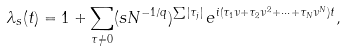Convert formula to latex. <formula><loc_0><loc_0><loc_500><loc_500>\lambda _ { s } ( t ) = 1 + \sum _ { \tau \neq 0 } ( s N ^ { - 1 / q } ) ^ { \sum | \tau _ { j } | } \, e ^ { i ( \tau _ { 1 } \nu + \tau _ { 2 } \nu ^ { 2 } + \dots + \tau _ { N } \nu ^ { N } ) t } ,</formula> 